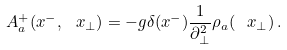Convert formula to latex. <formula><loc_0><loc_0><loc_500><loc_500>A _ { a } ^ { + } ( x ^ { - } , \ x _ { \perp } ) = - g \delta ( x ^ { - } ) \frac { 1 } { \partial _ { \perp } ^ { 2 } } \rho _ { a } ( \ x _ { \perp } ) \, .</formula> 